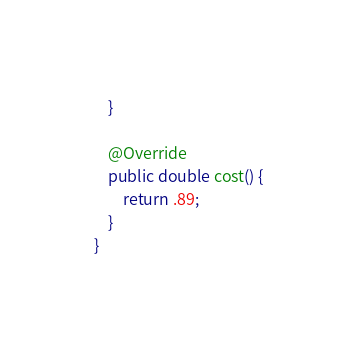Convert code to text. <code><loc_0><loc_0><loc_500><loc_500><_Java_>    }

    @Override
    public double cost() {
        return .89;
    }
}
</code> 